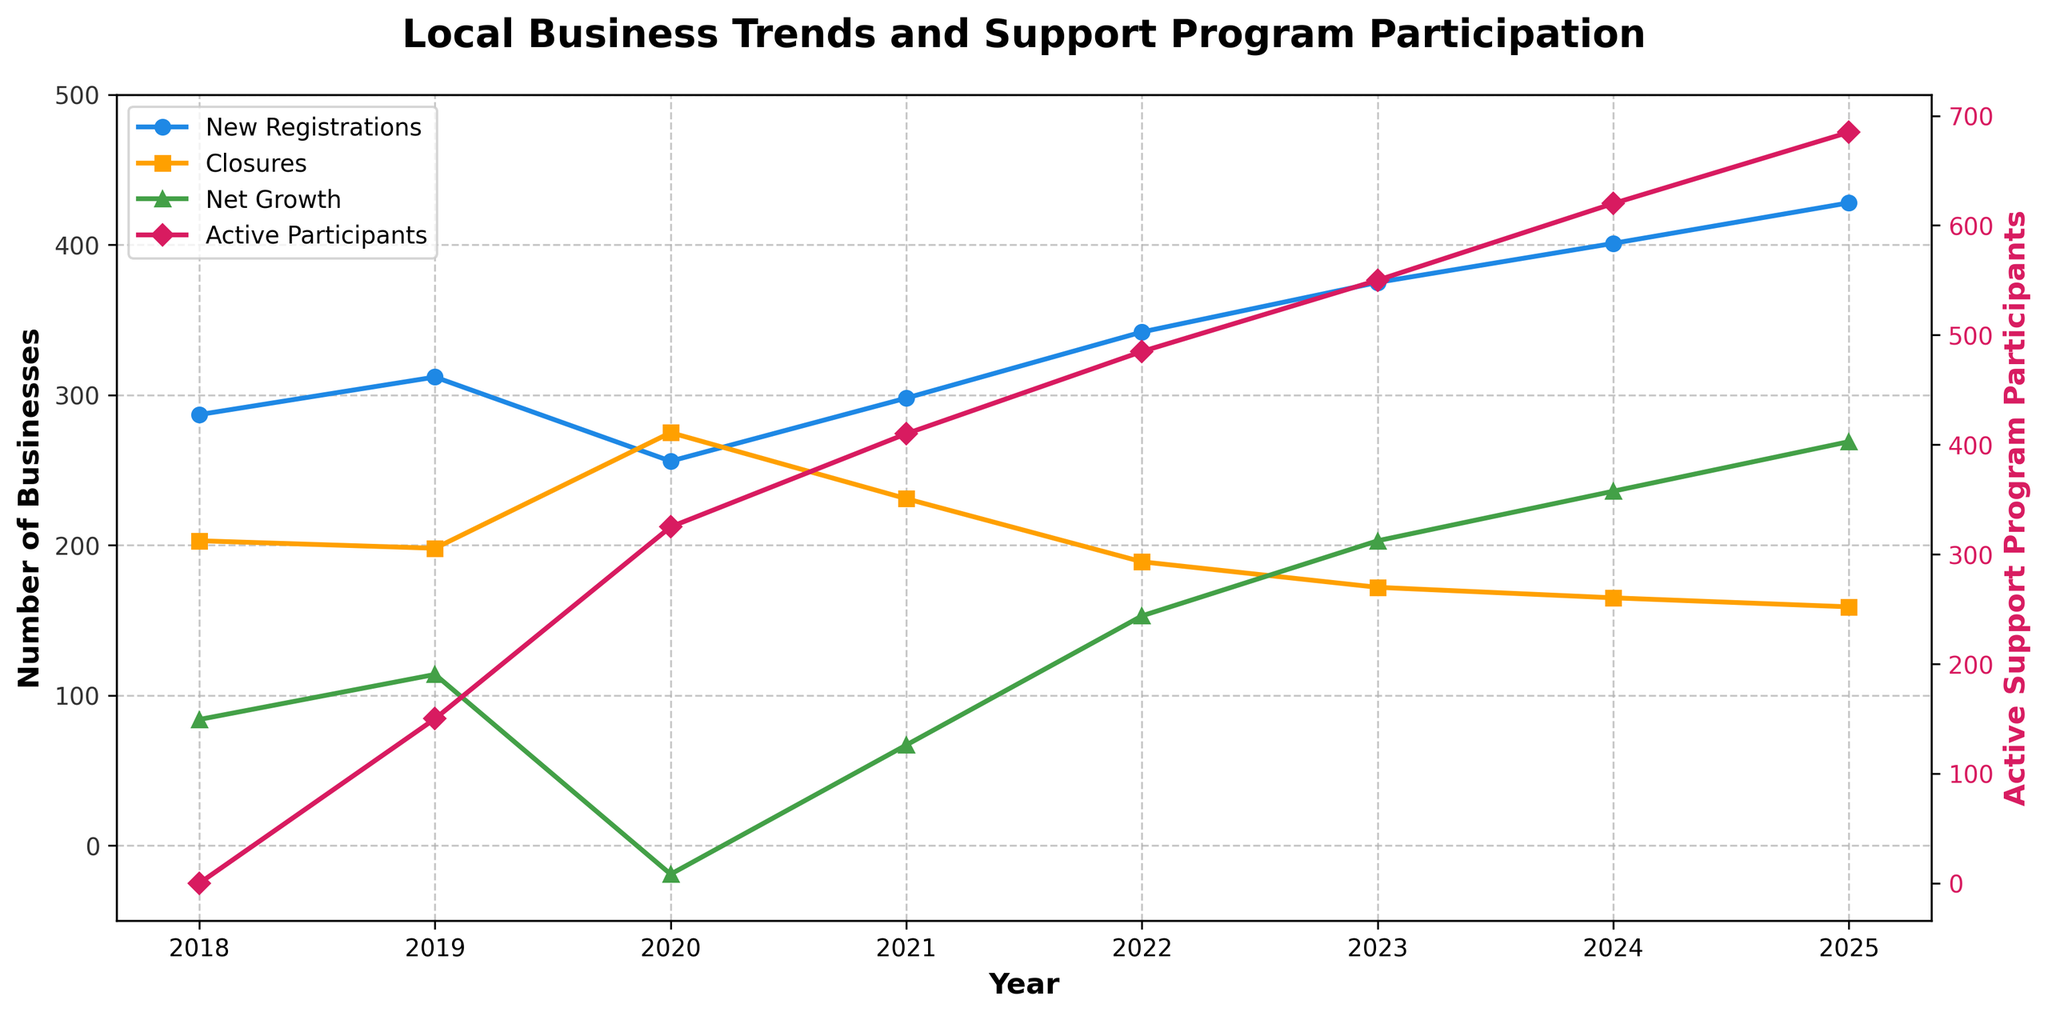What year had the highest net growth in business numbers? By looking at the green line representing "Net Growth," the highest point is in 2025.
Answer: 2025 How did the number of new business registrations change from 2019 to 2020? The blue line representing "New Business Registrations" shows a decrease from 312 in 2019 to 256 in 2020.
Answer: Decreased What was the difference in the number of active support program participants between 2020 and 2025? The number of participants in 2020 was 325 and in 2025 it was 685, so the difference is 685 - 325.
Answer: 360 Did business closures increase or decrease from 2020 to 2021? The orange line representing "Business Closures" shows a decrease from 275 in 2020 to 231 in 2021.
Answer: Decreased In what year did new business registrations exceed 400? By examining the blue line, new business registrations exceeded 400 in 2024.
Answer: 2024 Compare the number of business closures in 2018 and 2023. Which year had fewer closures? The orange line shows that business closures in 2018 were 203 and in 2023 were 172, so 2023 had fewer closures.
Answer: 2023 What was the net growth in 2021 and how does it compare to that in 2022? The green line shows net growth of 67 in 2021 and 153 in 2022, so the net growth is higher in 2022.
Answer: 2022 Describe the trend in the number of active support program participants from 2018 to 2025. The magenta line shows an increasing trend from 0 participants in 2018 to 685 participants in 2025.
Answer: Increasing How did net growth change from 2021 to 2022? The green line representing "Net Growth" shows an increase from 67 in 2021 to 153 in 2022.
Answer: Increased 